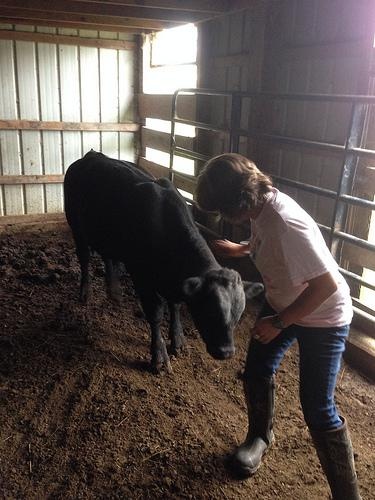Question: why is the floor dirt?
Choices:
A. An outside living room.
B. A vendor tent.
C. A hay barn.
D. It is a stable.
Answer with the letter. Answer: D Question: where are her boots?
Choices:
A. On her feet.
B. On her hands.
C. On the floor.
D. In the mud.
Answer with the letter. Answer: A Question: what is the cow doing?
Choices:
A. Grazing.
B. Staring at the camera.
C. Standing.
D. Stagnant.
Answer with the letter. Answer: C Question: what color is the girl's shirt?
Choices:
A. Pink.
B. Green.
C. Blue.
D. Brown.
Answer with the letter. Answer: A Question: who is in the picture?
Choices:
A. The girl.
B. A boy.
C. The woman.
D. A man.
Answer with the letter. Answer: A 